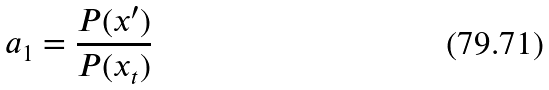Convert formula to latex. <formula><loc_0><loc_0><loc_500><loc_500>a _ { 1 } = \frac { P ( x ^ { \prime } ) } { P ( x _ { t } ) }</formula> 